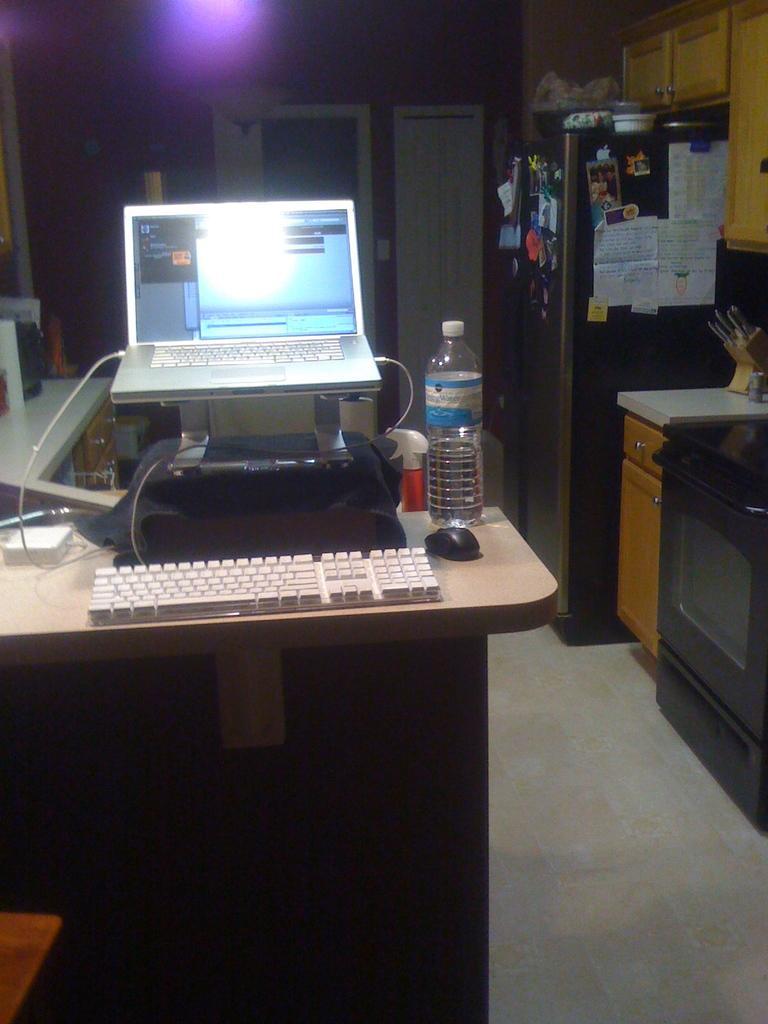How would you summarize this image in a sentence or two? As we can see in the image there is almara, wall, table. On table there is a screen, keyboard, mouse and bottle. 